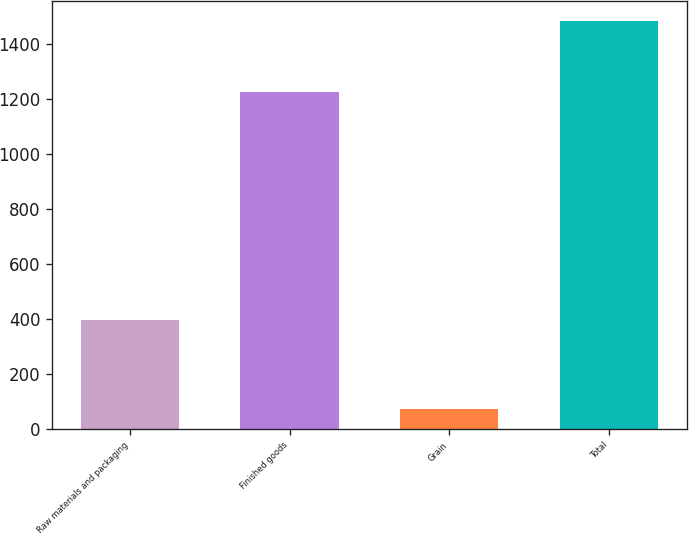Convert chart to OTSL. <chart><loc_0><loc_0><loc_500><loc_500><bar_chart><fcel>Raw materials and packaging<fcel>Finished goods<fcel>Grain<fcel>Total<nl><fcel>395.4<fcel>1224.3<fcel>73<fcel>1483.6<nl></chart> 